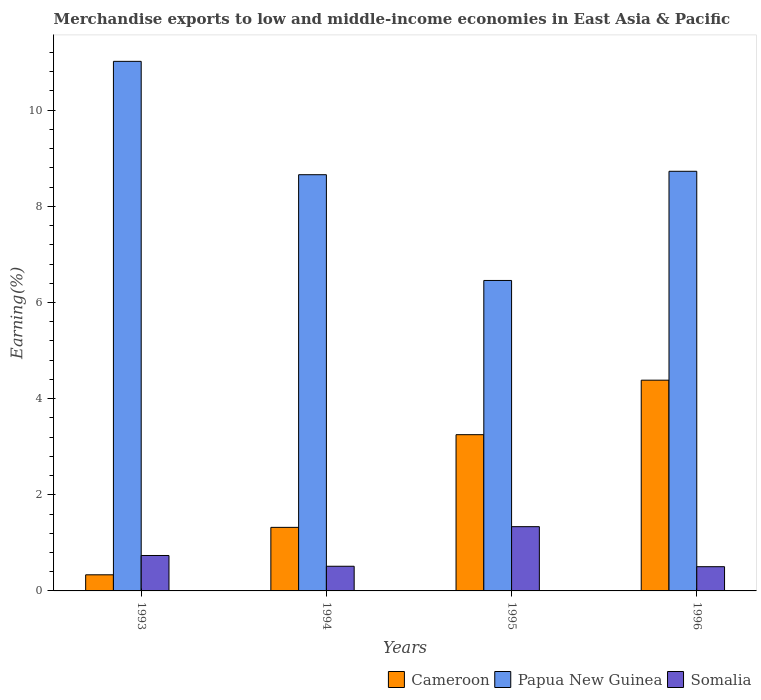How many different coloured bars are there?
Your answer should be compact. 3. Are the number of bars per tick equal to the number of legend labels?
Offer a terse response. Yes. Are the number of bars on each tick of the X-axis equal?
Make the answer very short. Yes. How many bars are there on the 3rd tick from the right?
Provide a short and direct response. 3. What is the percentage of amount earned from merchandise exports in Somalia in 1993?
Keep it short and to the point. 0.74. Across all years, what is the maximum percentage of amount earned from merchandise exports in Cameroon?
Make the answer very short. 4.38. Across all years, what is the minimum percentage of amount earned from merchandise exports in Papua New Guinea?
Your answer should be compact. 6.46. In which year was the percentage of amount earned from merchandise exports in Papua New Guinea maximum?
Ensure brevity in your answer.  1993. What is the total percentage of amount earned from merchandise exports in Cameroon in the graph?
Provide a short and direct response. 9.29. What is the difference between the percentage of amount earned from merchandise exports in Cameroon in 1993 and that in 1994?
Your answer should be very brief. -0.99. What is the difference between the percentage of amount earned from merchandise exports in Cameroon in 1993 and the percentage of amount earned from merchandise exports in Papua New Guinea in 1995?
Offer a terse response. -6.12. What is the average percentage of amount earned from merchandise exports in Cameroon per year?
Ensure brevity in your answer.  2.32. In the year 1993, what is the difference between the percentage of amount earned from merchandise exports in Cameroon and percentage of amount earned from merchandise exports in Somalia?
Provide a short and direct response. -0.4. What is the ratio of the percentage of amount earned from merchandise exports in Papua New Guinea in 1994 to that in 1995?
Offer a terse response. 1.34. What is the difference between the highest and the second highest percentage of amount earned from merchandise exports in Papua New Guinea?
Your answer should be compact. 2.29. What is the difference between the highest and the lowest percentage of amount earned from merchandise exports in Papua New Guinea?
Keep it short and to the point. 4.56. In how many years, is the percentage of amount earned from merchandise exports in Papua New Guinea greater than the average percentage of amount earned from merchandise exports in Papua New Guinea taken over all years?
Your answer should be very brief. 2. Is the sum of the percentage of amount earned from merchandise exports in Papua New Guinea in 1993 and 1996 greater than the maximum percentage of amount earned from merchandise exports in Cameroon across all years?
Give a very brief answer. Yes. What does the 2nd bar from the left in 1994 represents?
Make the answer very short. Papua New Guinea. What does the 1st bar from the right in 1994 represents?
Your answer should be very brief. Somalia. Is it the case that in every year, the sum of the percentage of amount earned from merchandise exports in Papua New Guinea and percentage of amount earned from merchandise exports in Cameroon is greater than the percentage of amount earned from merchandise exports in Somalia?
Provide a short and direct response. Yes. How many bars are there?
Your response must be concise. 12. How many years are there in the graph?
Keep it short and to the point. 4. What is the difference between two consecutive major ticks on the Y-axis?
Make the answer very short. 2. Does the graph contain grids?
Your answer should be compact. No. Where does the legend appear in the graph?
Give a very brief answer. Bottom right. What is the title of the graph?
Provide a succinct answer. Merchandise exports to low and middle-income economies in East Asia & Pacific. Does "American Samoa" appear as one of the legend labels in the graph?
Your answer should be compact. No. What is the label or title of the Y-axis?
Provide a short and direct response. Earning(%). What is the Earning(%) in Cameroon in 1993?
Offer a very short reply. 0.34. What is the Earning(%) of Papua New Guinea in 1993?
Your answer should be very brief. 11.02. What is the Earning(%) of Somalia in 1993?
Your answer should be compact. 0.74. What is the Earning(%) in Cameroon in 1994?
Your answer should be compact. 1.32. What is the Earning(%) of Papua New Guinea in 1994?
Offer a terse response. 8.66. What is the Earning(%) in Somalia in 1994?
Provide a short and direct response. 0.51. What is the Earning(%) in Cameroon in 1995?
Your answer should be compact. 3.25. What is the Earning(%) of Papua New Guinea in 1995?
Make the answer very short. 6.46. What is the Earning(%) of Somalia in 1995?
Your answer should be very brief. 1.34. What is the Earning(%) of Cameroon in 1996?
Your answer should be compact. 4.38. What is the Earning(%) in Papua New Guinea in 1996?
Give a very brief answer. 8.73. What is the Earning(%) in Somalia in 1996?
Your answer should be compact. 0.5. Across all years, what is the maximum Earning(%) of Cameroon?
Your answer should be compact. 4.38. Across all years, what is the maximum Earning(%) of Papua New Guinea?
Offer a terse response. 11.02. Across all years, what is the maximum Earning(%) of Somalia?
Offer a very short reply. 1.34. Across all years, what is the minimum Earning(%) in Cameroon?
Provide a succinct answer. 0.34. Across all years, what is the minimum Earning(%) of Papua New Guinea?
Your answer should be compact. 6.46. Across all years, what is the minimum Earning(%) in Somalia?
Your answer should be very brief. 0.5. What is the total Earning(%) of Cameroon in the graph?
Offer a terse response. 9.29. What is the total Earning(%) in Papua New Guinea in the graph?
Offer a terse response. 34.86. What is the total Earning(%) of Somalia in the graph?
Your response must be concise. 3.09. What is the difference between the Earning(%) of Cameroon in 1993 and that in 1994?
Your response must be concise. -0.99. What is the difference between the Earning(%) of Papua New Guinea in 1993 and that in 1994?
Your answer should be very brief. 2.36. What is the difference between the Earning(%) of Somalia in 1993 and that in 1994?
Provide a succinct answer. 0.22. What is the difference between the Earning(%) in Cameroon in 1993 and that in 1995?
Offer a terse response. -2.91. What is the difference between the Earning(%) in Papua New Guinea in 1993 and that in 1995?
Provide a short and direct response. 4.56. What is the difference between the Earning(%) of Somalia in 1993 and that in 1995?
Provide a succinct answer. -0.6. What is the difference between the Earning(%) of Cameroon in 1993 and that in 1996?
Give a very brief answer. -4.05. What is the difference between the Earning(%) in Papua New Guinea in 1993 and that in 1996?
Offer a terse response. 2.29. What is the difference between the Earning(%) in Somalia in 1993 and that in 1996?
Offer a very short reply. 0.23. What is the difference between the Earning(%) in Cameroon in 1994 and that in 1995?
Provide a succinct answer. -1.93. What is the difference between the Earning(%) in Papua New Guinea in 1994 and that in 1995?
Your response must be concise. 2.2. What is the difference between the Earning(%) in Somalia in 1994 and that in 1995?
Provide a succinct answer. -0.82. What is the difference between the Earning(%) of Cameroon in 1994 and that in 1996?
Keep it short and to the point. -3.06. What is the difference between the Earning(%) in Papua New Guinea in 1994 and that in 1996?
Make the answer very short. -0.07. What is the difference between the Earning(%) in Somalia in 1994 and that in 1996?
Offer a very short reply. 0.01. What is the difference between the Earning(%) in Cameroon in 1995 and that in 1996?
Your answer should be compact. -1.13. What is the difference between the Earning(%) of Papua New Guinea in 1995 and that in 1996?
Keep it short and to the point. -2.27. What is the difference between the Earning(%) in Somalia in 1995 and that in 1996?
Provide a succinct answer. 0.83. What is the difference between the Earning(%) of Cameroon in 1993 and the Earning(%) of Papua New Guinea in 1994?
Your answer should be compact. -8.32. What is the difference between the Earning(%) in Cameroon in 1993 and the Earning(%) in Somalia in 1994?
Offer a very short reply. -0.18. What is the difference between the Earning(%) of Papua New Guinea in 1993 and the Earning(%) of Somalia in 1994?
Your response must be concise. 10.5. What is the difference between the Earning(%) of Cameroon in 1993 and the Earning(%) of Papua New Guinea in 1995?
Offer a very short reply. -6.12. What is the difference between the Earning(%) of Cameroon in 1993 and the Earning(%) of Somalia in 1995?
Your response must be concise. -1. What is the difference between the Earning(%) in Papua New Guinea in 1993 and the Earning(%) in Somalia in 1995?
Give a very brief answer. 9.68. What is the difference between the Earning(%) in Cameroon in 1993 and the Earning(%) in Papua New Guinea in 1996?
Offer a very short reply. -8.39. What is the difference between the Earning(%) of Cameroon in 1993 and the Earning(%) of Somalia in 1996?
Provide a succinct answer. -0.17. What is the difference between the Earning(%) of Papua New Guinea in 1993 and the Earning(%) of Somalia in 1996?
Your answer should be very brief. 10.51. What is the difference between the Earning(%) in Cameroon in 1994 and the Earning(%) in Papua New Guinea in 1995?
Your answer should be very brief. -5.14. What is the difference between the Earning(%) in Cameroon in 1994 and the Earning(%) in Somalia in 1995?
Your answer should be very brief. -0.01. What is the difference between the Earning(%) in Papua New Guinea in 1994 and the Earning(%) in Somalia in 1995?
Your answer should be very brief. 7.32. What is the difference between the Earning(%) of Cameroon in 1994 and the Earning(%) of Papua New Guinea in 1996?
Provide a short and direct response. -7.41. What is the difference between the Earning(%) in Cameroon in 1994 and the Earning(%) in Somalia in 1996?
Your answer should be very brief. 0.82. What is the difference between the Earning(%) of Papua New Guinea in 1994 and the Earning(%) of Somalia in 1996?
Make the answer very short. 8.15. What is the difference between the Earning(%) in Cameroon in 1995 and the Earning(%) in Papua New Guinea in 1996?
Provide a short and direct response. -5.48. What is the difference between the Earning(%) of Cameroon in 1995 and the Earning(%) of Somalia in 1996?
Offer a terse response. 2.75. What is the difference between the Earning(%) of Papua New Guinea in 1995 and the Earning(%) of Somalia in 1996?
Provide a succinct answer. 5.95. What is the average Earning(%) of Cameroon per year?
Give a very brief answer. 2.32. What is the average Earning(%) of Papua New Guinea per year?
Keep it short and to the point. 8.72. What is the average Earning(%) of Somalia per year?
Offer a very short reply. 0.77. In the year 1993, what is the difference between the Earning(%) of Cameroon and Earning(%) of Papua New Guinea?
Provide a short and direct response. -10.68. In the year 1993, what is the difference between the Earning(%) in Cameroon and Earning(%) in Somalia?
Give a very brief answer. -0.4. In the year 1993, what is the difference between the Earning(%) of Papua New Guinea and Earning(%) of Somalia?
Keep it short and to the point. 10.28. In the year 1994, what is the difference between the Earning(%) of Cameroon and Earning(%) of Papua New Guinea?
Provide a succinct answer. -7.34. In the year 1994, what is the difference between the Earning(%) in Cameroon and Earning(%) in Somalia?
Make the answer very short. 0.81. In the year 1994, what is the difference between the Earning(%) of Papua New Guinea and Earning(%) of Somalia?
Give a very brief answer. 8.15. In the year 1995, what is the difference between the Earning(%) of Cameroon and Earning(%) of Papua New Guinea?
Your answer should be compact. -3.21. In the year 1995, what is the difference between the Earning(%) of Cameroon and Earning(%) of Somalia?
Offer a very short reply. 1.91. In the year 1995, what is the difference between the Earning(%) of Papua New Guinea and Earning(%) of Somalia?
Make the answer very short. 5.12. In the year 1996, what is the difference between the Earning(%) in Cameroon and Earning(%) in Papua New Guinea?
Your answer should be very brief. -4.35. In the year 1996, what is the difference between the Earning(%) of Cameroon and Earning(%) of Somalia?
Ensure brevity in your answer.  3.88. In the year 1996, what is the difference between the Earning(%) of Papua New Guinea and Earning(%) of Somalia?
Ensure brevity in your answer.  8.23. What is the ratio of the Earning(%) in Cameroon in 1993 to that in 1994?
Give a very brief answer. 0.25. What is the ratio of the Earning(%) in Papua New Guinea in 1993 to that in 1994?
Offer a very short reply. 1.27. What is the ratio of the Earning(%) in Somalia in 1993 to that in 1994?
Offer a very short reply. 1.44. What is the ratio of the Earning(%) of Cameroon in 1993 to that in 1995?
Your answer should be very brief. 0.1. What is the ratio of the Earning(%) in Papua New Guinea in 1993 to that in 1995?
Keep it short and to the point. 1.71. What is the ratio of the Earning(%) in Somalia in 1993 to that in 1995?
Your answer should be compact. 0.55. What is the ratio of the Earning(%) of Cameroon in 1993 to that in 1996?
Give a very brief answer. 0.08. What is the ratio of the Earning(%) in Papua New Guinea in 1993 to that in 1996?
Offer a terse response. 1.26. What is the ratio of the Earning(%) of Somalia in 1993 to that in 1996?
Give a very brief answer. 1.46. What is the ratio of the Earning(%) in Cameroon in 1994 to that in 1995?
Keep it short and to the point. 0.41. What is the ratio of the Earning(%) in Papua New Guinea in 1994 to that in 1995?
Your answer should be compact. 1.34. What is the ratio of the Earning(%) in Somalia in 1994 to that in 1995?
Your answer should be compact. 0.38. What is the ratio of the Earning(%) of Cameroon in 1994 to that in 1996?
Your answer should be very brief. 0.3. What is the ratio of the Earning(%) in Somalia in 1994 to that in 1996?
Ensure brevity in your answer.  1.02. What is the ratio of the Earning(%) of Cameroon in 1995 to that in 1996?
Your response must be concise. 0.74. What is the ratio of the Earning(%) in Papua New Guinea in 1995 to that in 1996?
Your answer should be very brief. 0.74. What is the ratio of the Earning(%) of Somalia in 1995 to that in 1996?
Offer a terse response. 2.65. What is the difference between the highest and the second highest Earning(%) in Cameroon?
Your response must be concise. 1.13. What is the difference between the highest and the second highest Earning(%) in Papua New Guinea?
Provide a short and direct response. 2.29. What is the difference between the highest and the second highest Earning(%) in Somalia?
Ensure brevity in your answer.  0.6. What is the difference between the highest and the lowest Earning(%) of Cameroon?
Ensure brevity in your answer.  4.05. What is the difference between the highest and the lowest Earning(%) in Papua New Guinea?
Provide a succinct answer. 4.56. What is the difference between the highest and the lowest Earning(%) in Somalia?
Ensure brevity in your answer.  0.83. 